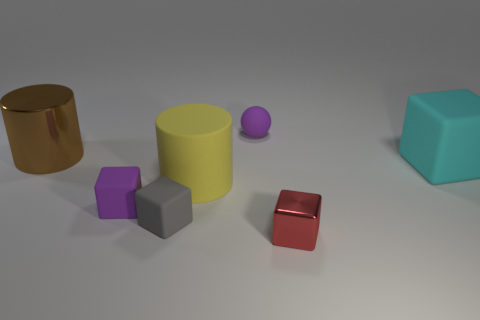Add 3 blue blocks. How many objects exist? 10 Subtract all spheres. How many objects are left? 6 Add 4 small rubber spheres. How many small rubber spheres are left? 5 Add 1 small cyan shiny cylinders. How many small cyan shiny cylinders exist? 1 Subtract 1 cyan blocks. How many objects are left? 6 Subtract all tiny rubber things. Subtract all big cyan rubber cubes. How many objects are left? 3 